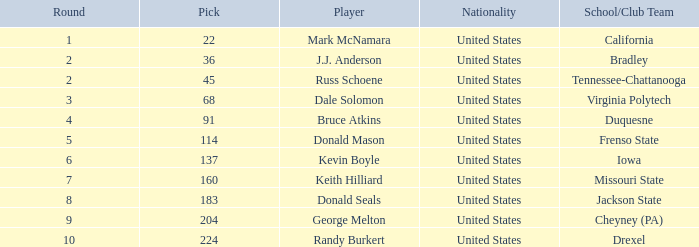What is the country of origin for the drexel player who had a choice above 183? United States. 